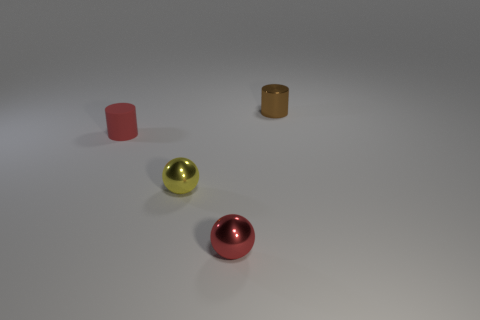Imagine this as a scene from a story. What characters could interact with these objects, and what might be their significance? In a whimsical story, these objects might be precious items collected by a futuristic robotic character who perceives them as remnants of human culture. Each object could represent different human traits or memories, giving them a symbolic significance in the robot's quest to understand humanity. 